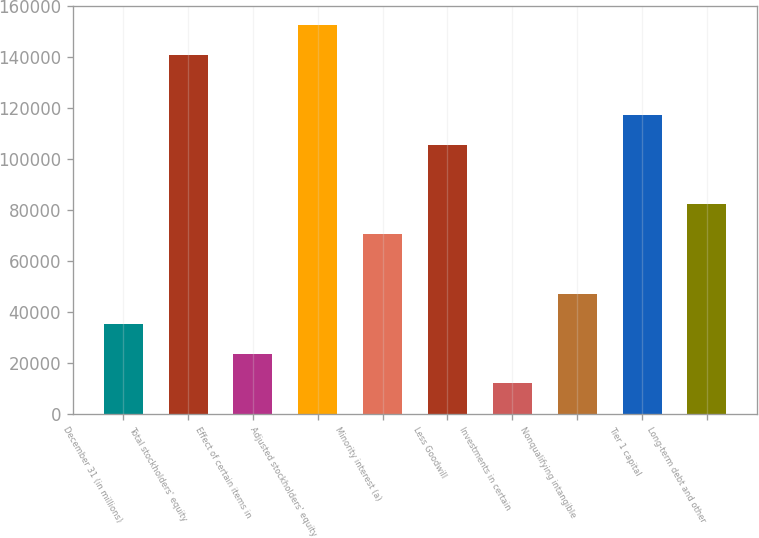Convert chart. <chart><loc_0><loc_0><loc_500><loc_500><bar_chart><fcel>December 31 (in millions)<fcel>Total stockholders' equity<fcel>Effect of certain items in<fcel>Adjusted stockholders' equity<fcel>Minority interest (a)<fcel>Less Goodwill<fcel>Investments in certain<fcel>Nonqualifying intangible<fcel>Tier 1 capital<fcel>Long-term debt and other<nl><fcel>35349.8<fcel>140781<fcel>23635.2<fcel>152496<fcel>70493.6<fcel>105637<fcel>11920.6<fcel>47064.4<fcel>117352<fcel>82208.2<nl></chart> 